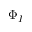Convert formula to latex. <formula><loc_0><loc_0><loc_500><loc_500>\Phi _ { I }</formula> 